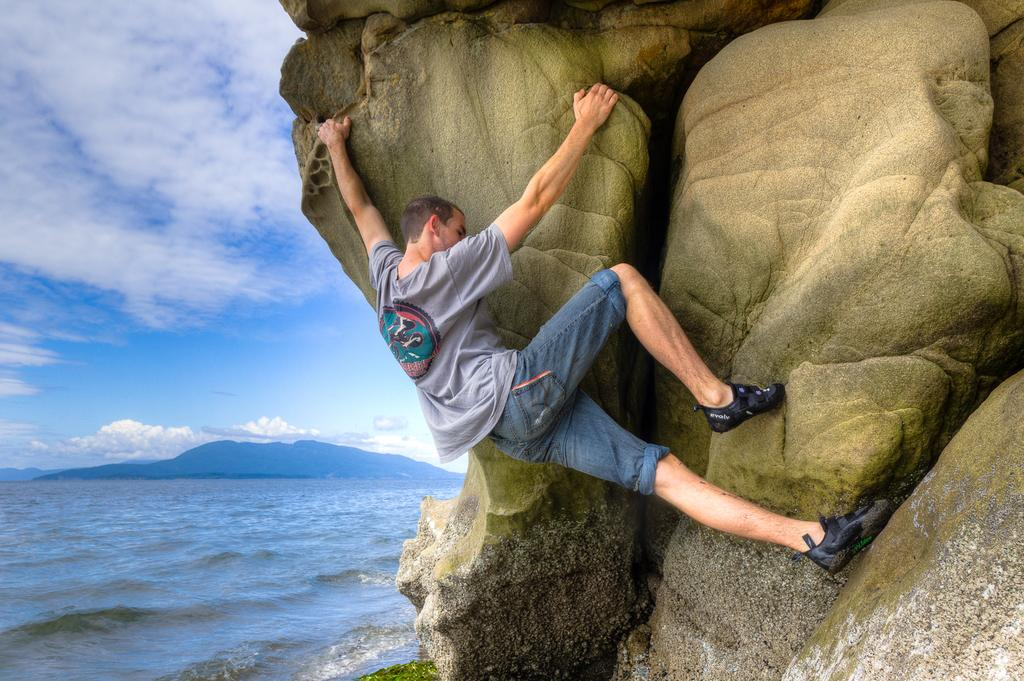What is the main activity of the person in the image? There is a person climbing a mountain in the image. What natural element can be seen in the image besides the mountains? There is water visible in the image. How many mountains are visible in the image? There are mountains in the image. What is visible above the mountains in the image? The sky is visible in the image. What type of paste is being used by the person climbing the mountain in the image? There is no paste visible or mentioned in the image; the person is climbing a mountain. 